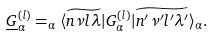<formula> <loc_0><loc_0><loc_500><loc_500>\underline { G } _ { \alpha } ^ { ( l ) } = _ { \alpha } \langle \widetilde { n \nu l \lambda } | G _ { \alpha } ^ { ( l ) } | \widetilde { n ^ { \prime } \nu ^ { \prime } { l ^ { \prime } } { \lambda ^ { \prime } } } \rangle _ { \alpha } .</formula> 